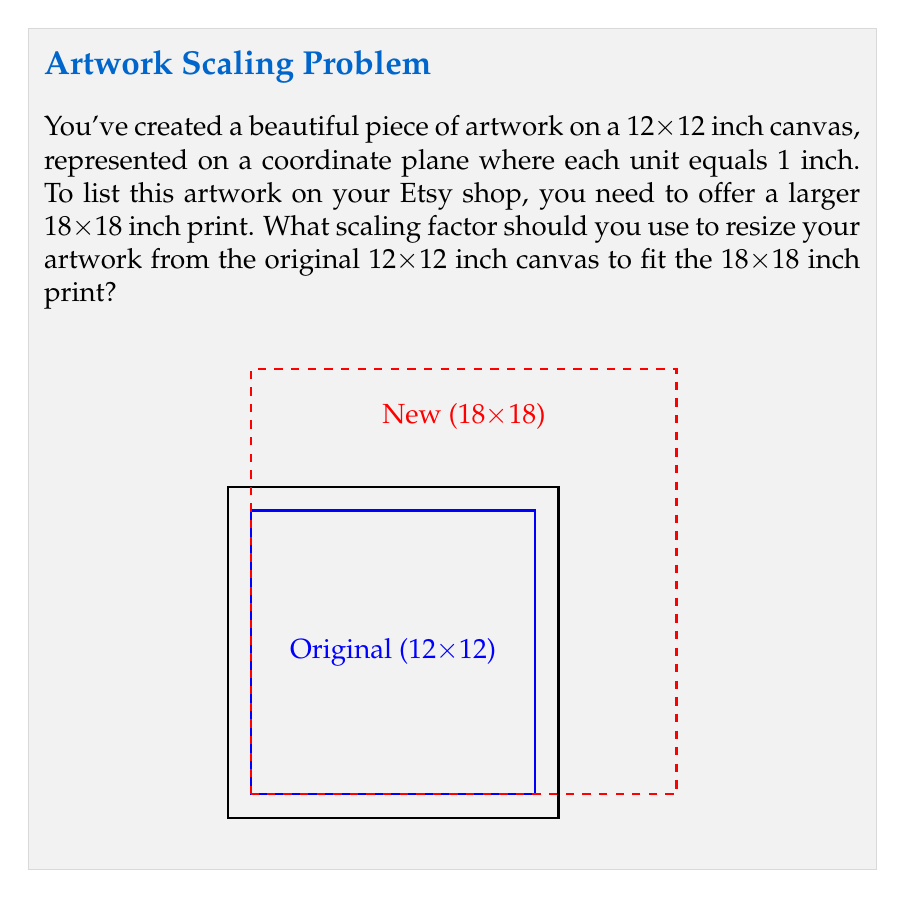Give your solution to this math problem. To find the scaling factor, we need to compare the dimensions of the new print to the original artwork. Let's approach this step-by-step:

1) The original artwork is on a 12x12 inch canvas.
2) The new print size is 18x18 inches.

3) To calculate the scaling factor, we divide the new size by the original size:

   $$ \text{Scaling Factor} = \frac{\text{New Size}}{\text{Original Size}} $$

4) We can use either the width or height for this calculation, as the scaling should be uniform to maintain the artwork's proportions:

   $$ \text{Scaling Factor} = \frac{18 \text{ inches}}{12 \text{ inches}} $$

5) Simplify the fraction:

   $$ \text{Scaling Factor} = \frac{18}{12} = \frac{3}{2} = 1.5 $$

This means that each dimension of the original artwork needs to be multiplied by 1.5 to fit the new 18x18 inch print size.
Answer: $1.5$ 